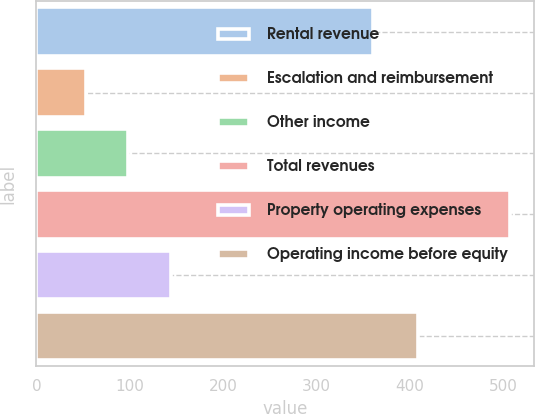Convert chart. <chart><loc_0><loc_0><loc_500><loc_500><bar_chart><fcel>Rental revenue<fcel>Escalation and reimbursement<fcel>Other income<fcel>Total revenues<fcel>Property operating expenses<fcel>Operating income before equity<nl><fcel>360.7<fcel>52.7<fcel>98.2<fcel>507.7<fcel>143.7<fcel>409<nl></chart> 